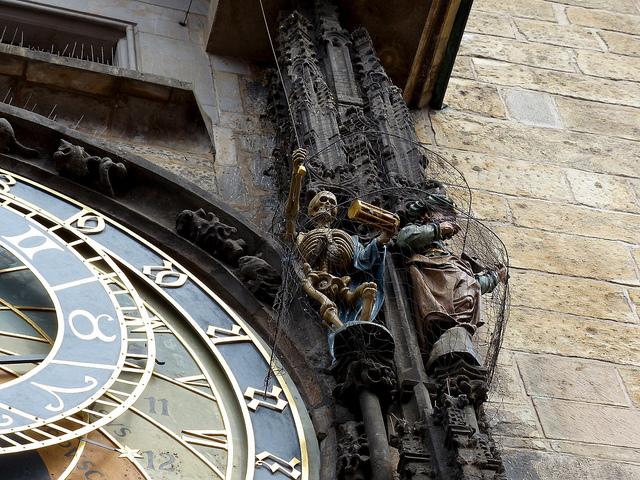Is this building made of stone?
Give a very brief answer. Yes. Is this photo real?
Keep it brief. Yes. What is the Skeleton holding?
Give a very brief answer. Gold box. 